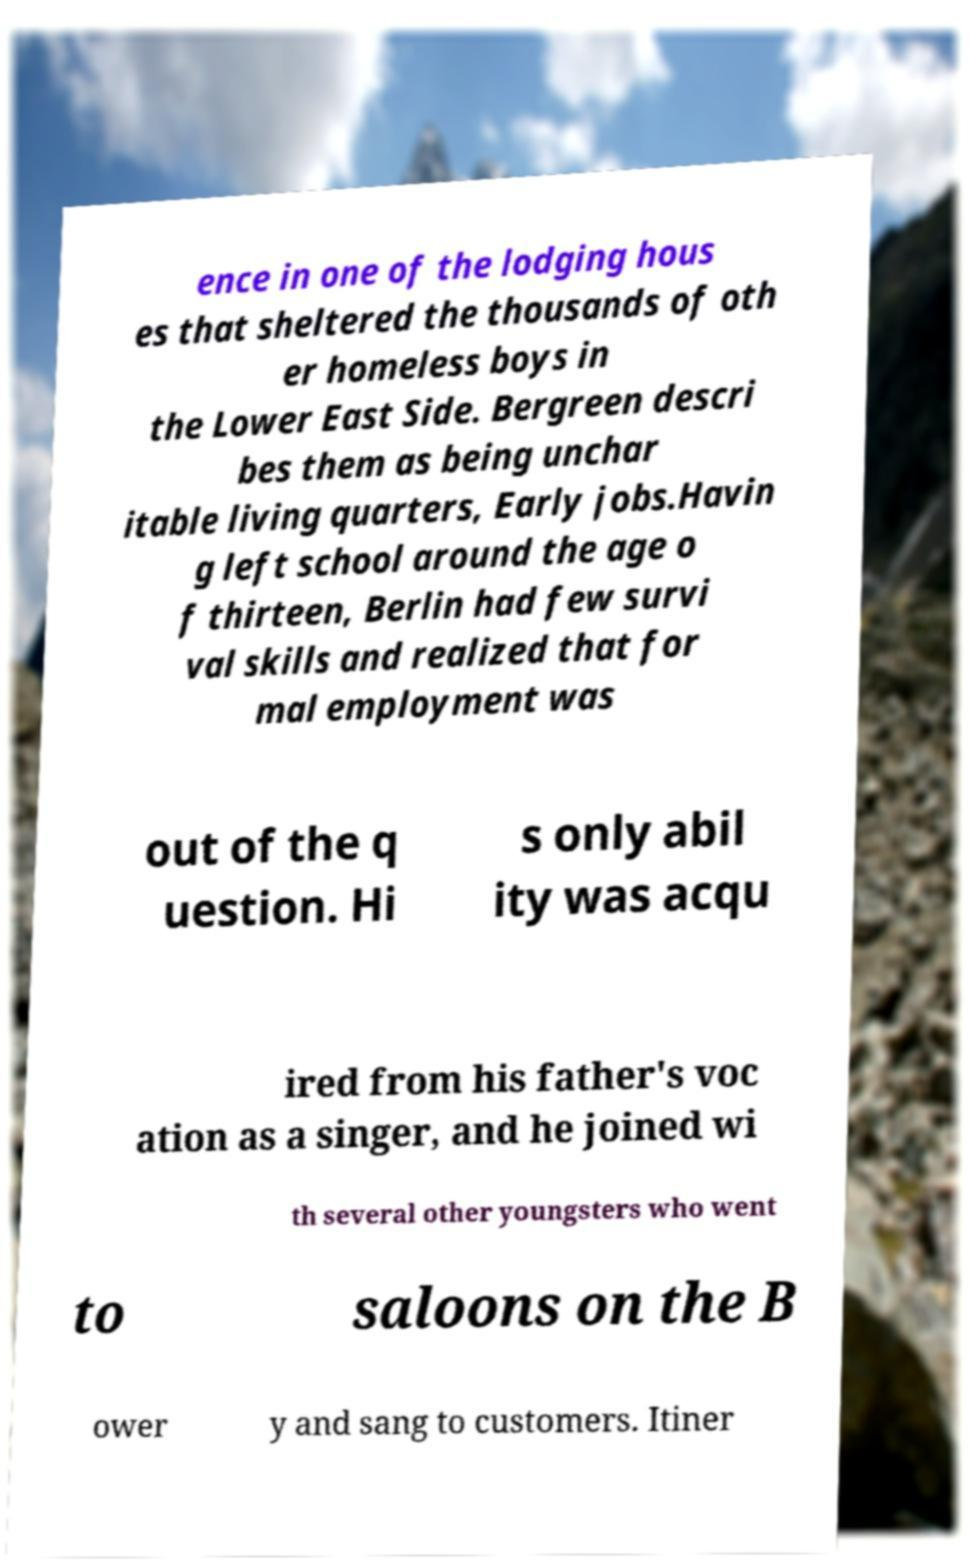I need the written content from this picture converted into text. Can you do that? ence in one of the lodging hous es that sheltered the thousands of oth er homeless boys in the Lower East Side. Bergreen descri bes them as being unchar itable living quarters, Early jobs.Havin g left school around the age o f thirteen, Berlin had few survi val skills and realized that for mal employment was out of the q uestion. Hi s only abil ity was acqu ired from his father's voc ation as a singer, and he joined wi th several other youngsters who went to saloons on the B ower y and sang to customers. Itiner 